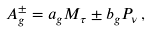Convert formula to latex. <formula><loc_0><loc_0><loc_500><loc_500>A ^ { \pm } _ { g } = a _ { g } M _ { \tau } \pm b _ { g } P _ { \nu } \, ,</formula> 